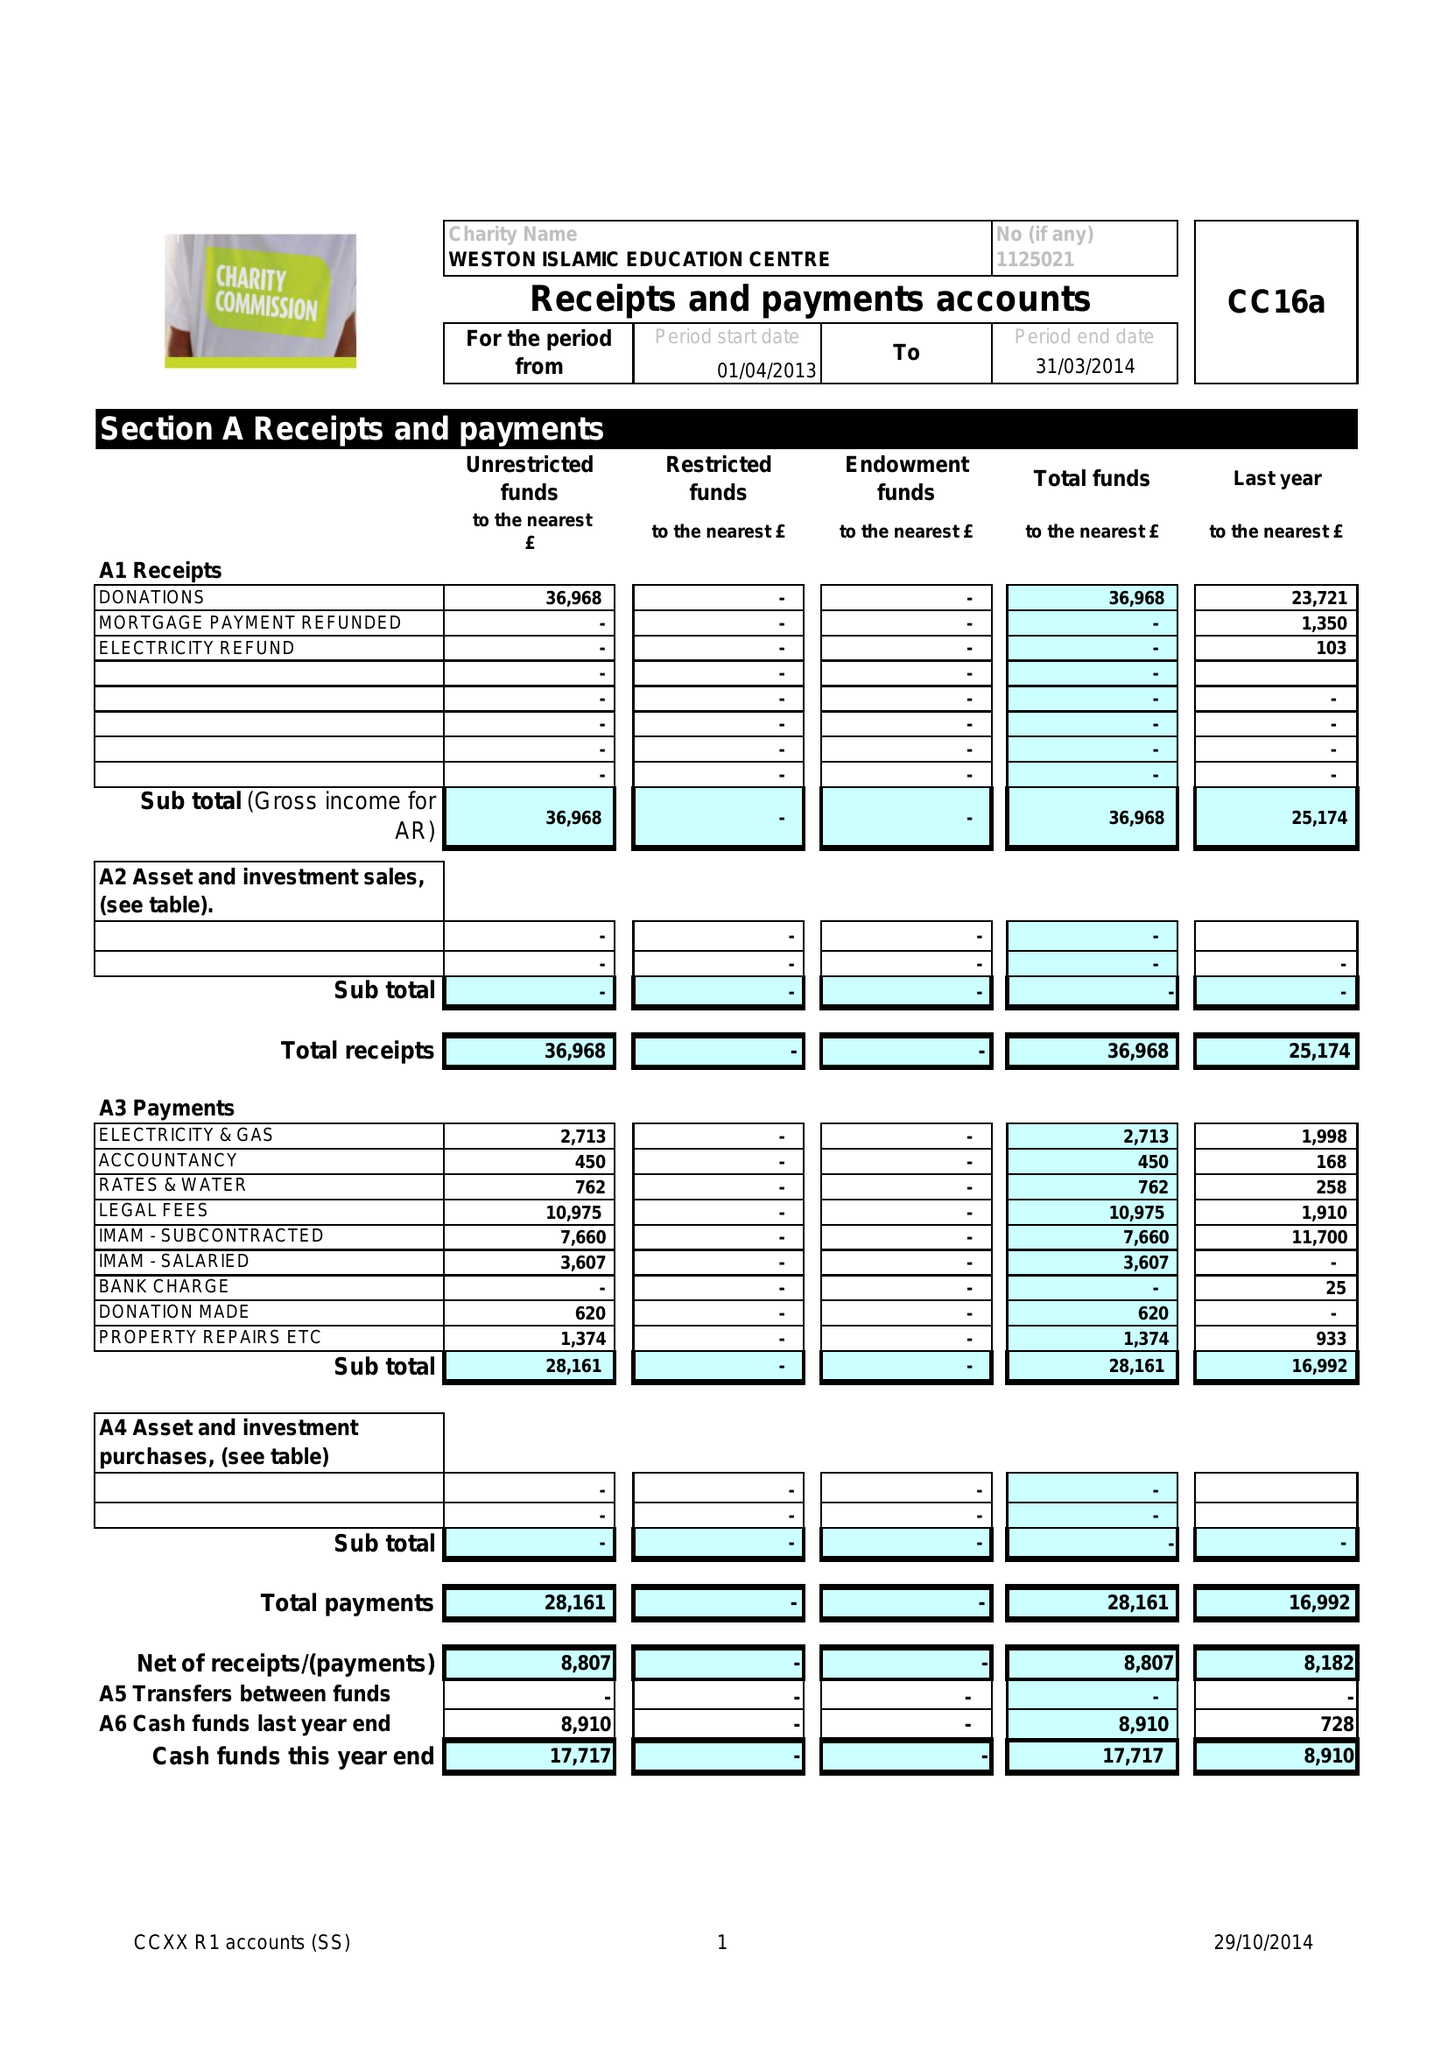What is the value for the address__post_town?
Answer the question using a single word or phrase. WESTON-SUPER-MARE 